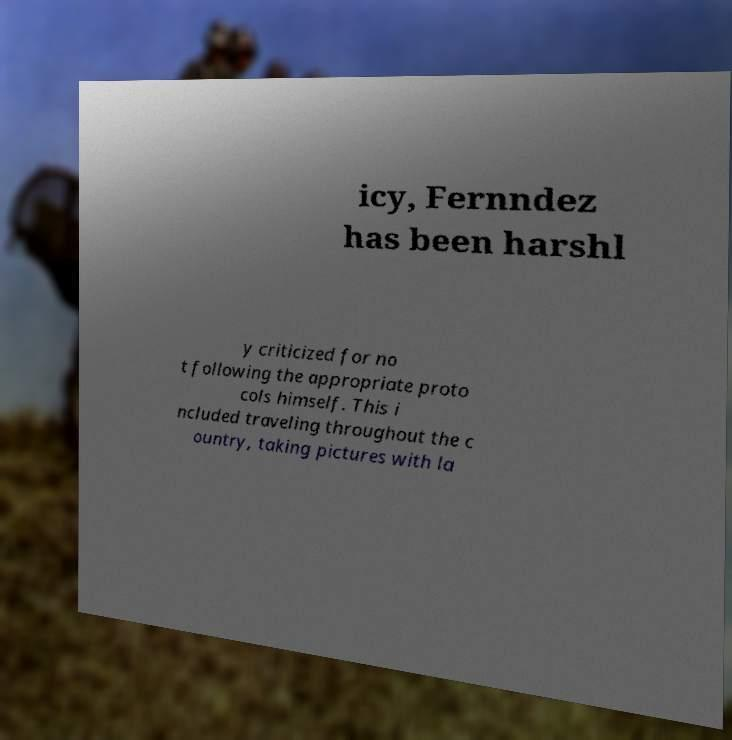Can you accurately transcribe the text from the provided image for me? icy, Fernndez has been harshl y criticized for no t following the appropriate proto cols himself. This i ncluded traveling throughout the c ountry, taking pictures with la 